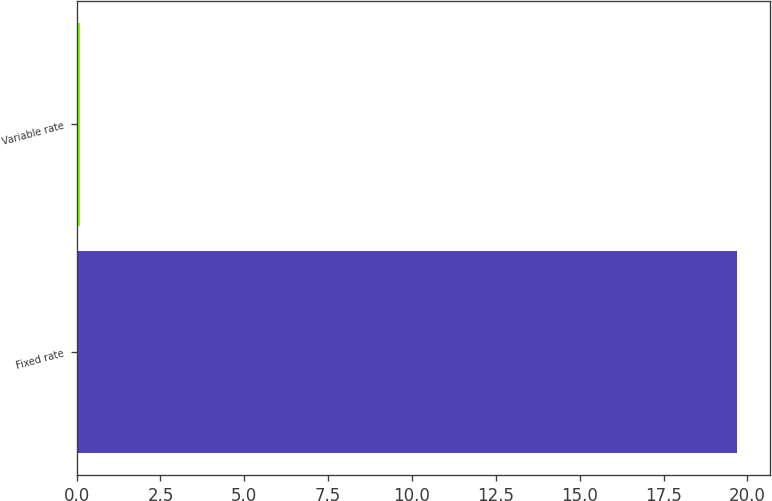Convert chart. <chart><loc_0><loc_0><loc_500><loc_500><bar_chart><fcel>Fixed rate<fcel>Variable rate<nl><fcel>19.7<fcel>0.1<nl></chart> 